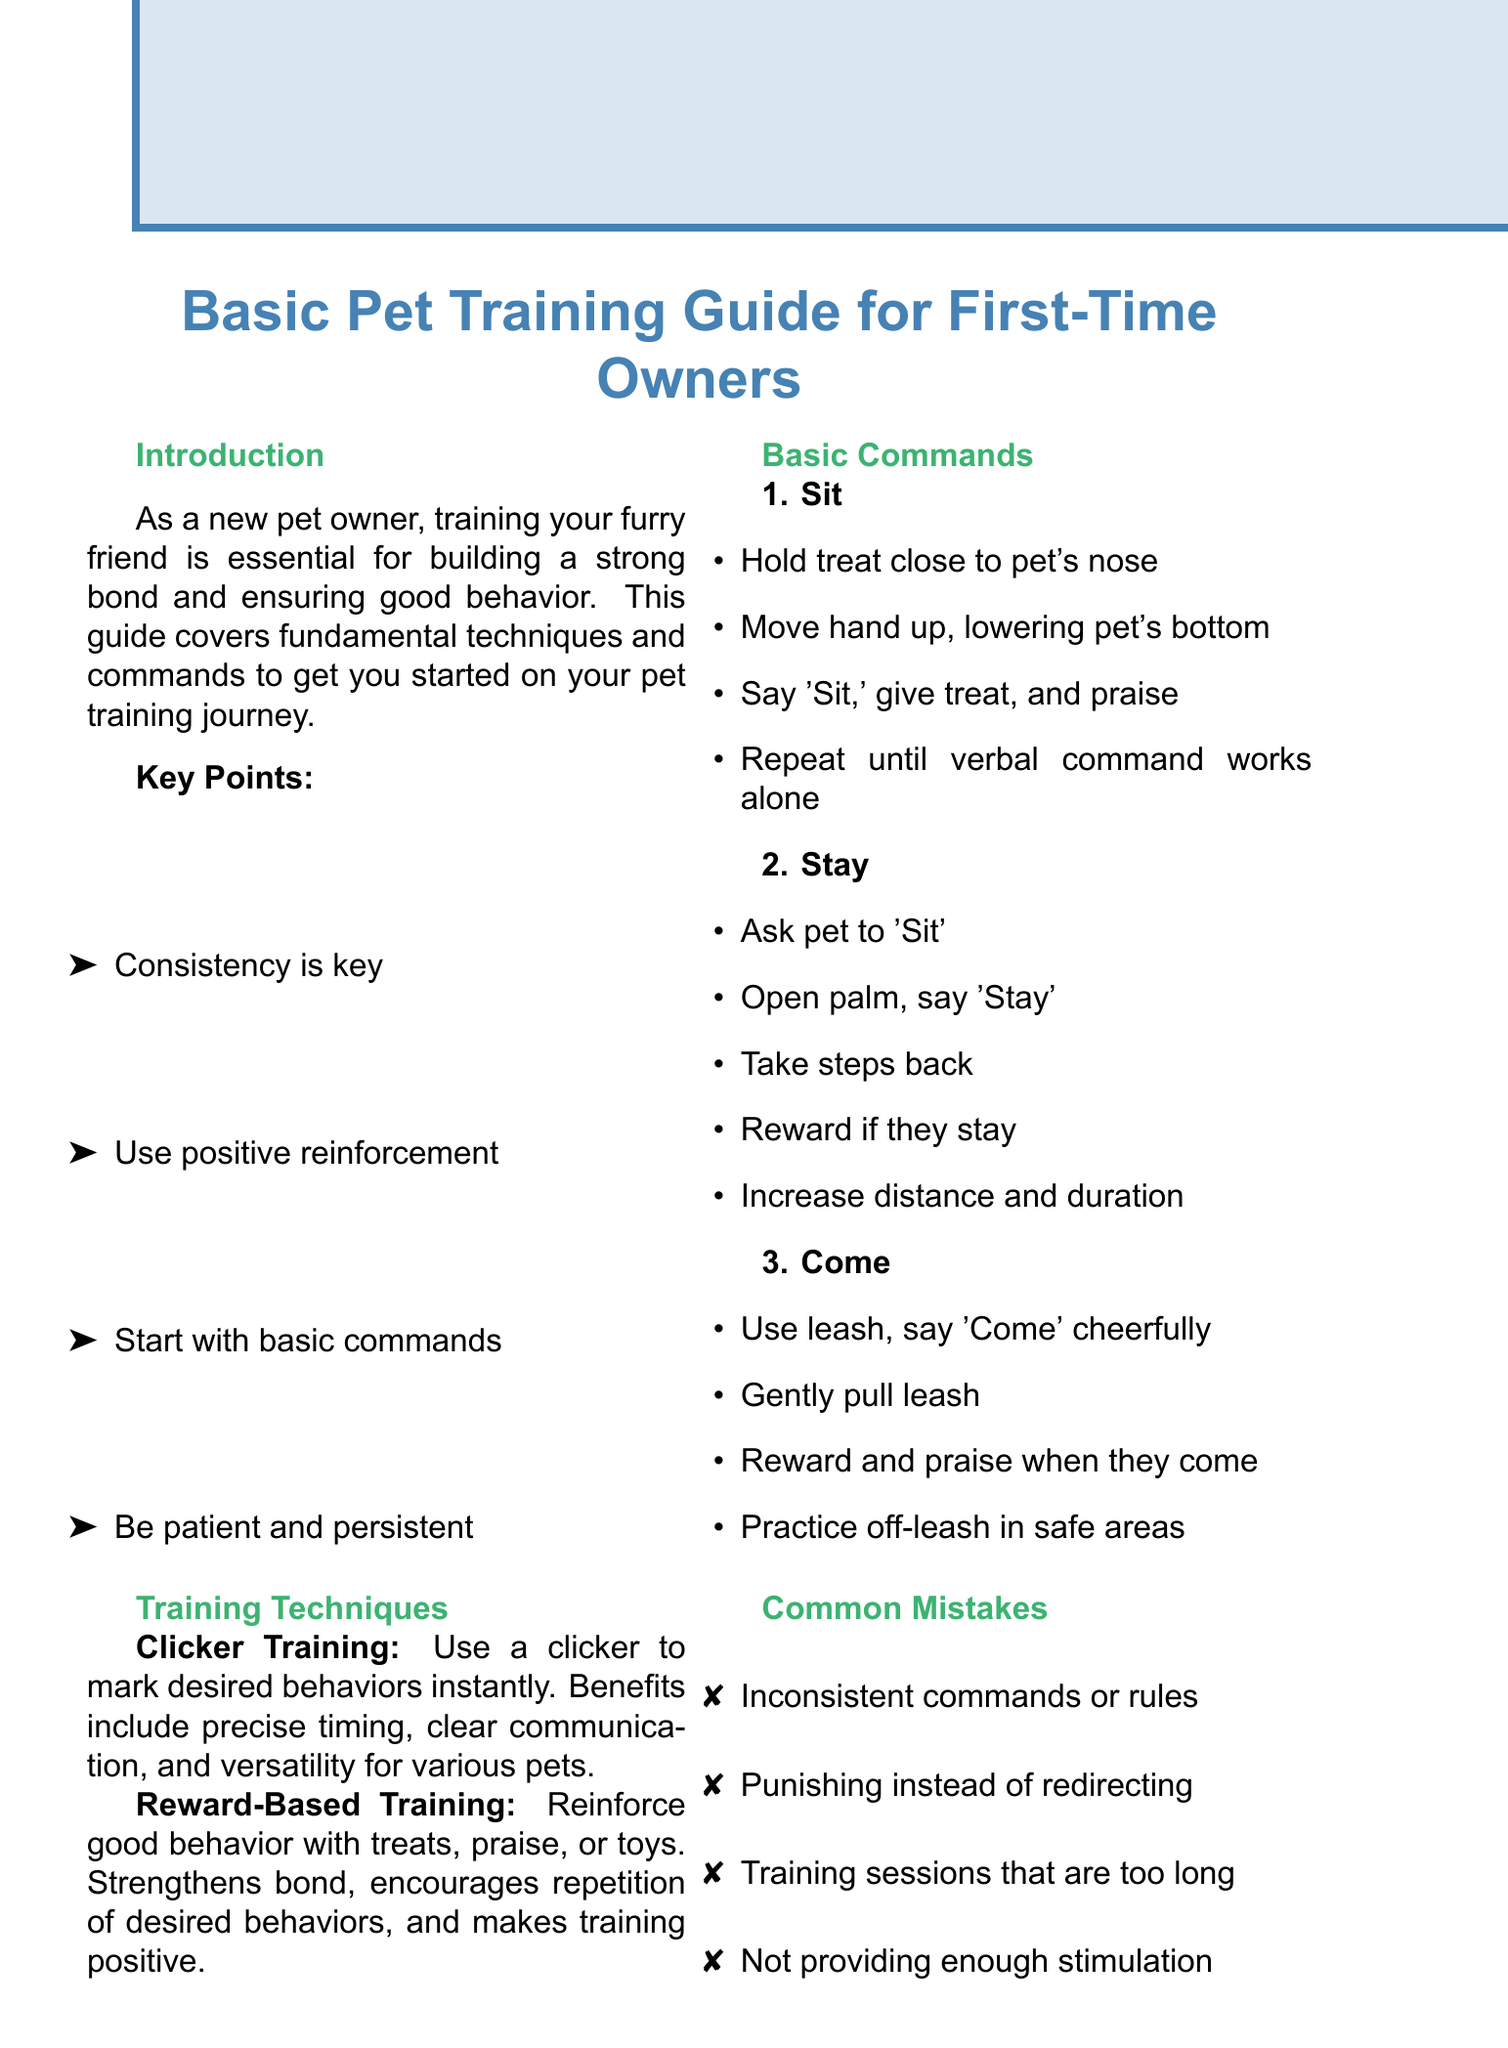what is the title of the memo? The title of the memo is stated at the beginning of the document, which summarizes the content.
Answer: Basic Pet Training Guide for First-Time Owners what is a key point mentioned in the introduction? The introduction lists several key points crucial for training a pet.
Answer: Consistency is key what is the first command listed in the basic commands section? The basic commands section enumerates several commands in a specific order.
Answer: Sit how many weekly entries are provided in the progress log? The progress log includes a specific number of weeks to track progress.
Answer: 4 what training technique uses a clicker? The document describes various training techniques and one specifies using a clicker.
Answer: Clicker Training what are the common mistakes listed in the document? The document outlines several common errors made during pet training.
Answer: Inconsistent commands or rules what is the milestone for the "Come" command? Each command includes a milestone to track progress, particularly for the "Come" command.
Answer: Responds reliably off-leash in distracting environments how many resources are listed under books? The resources section enumerates types of resources available for pet training.
Answer: 2 what is a final tip mentioned in the conclusion? The conclusion provides several tips to enhance the training experience for pets.
Answer: Celebrate small victories 